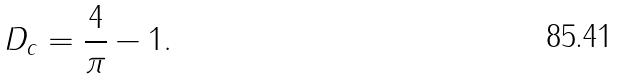<formula> <loc_0><loc_0><loc_500><loc_500>D _ { c } = \frac { 4 } { \pi } - 1 .</formula> 